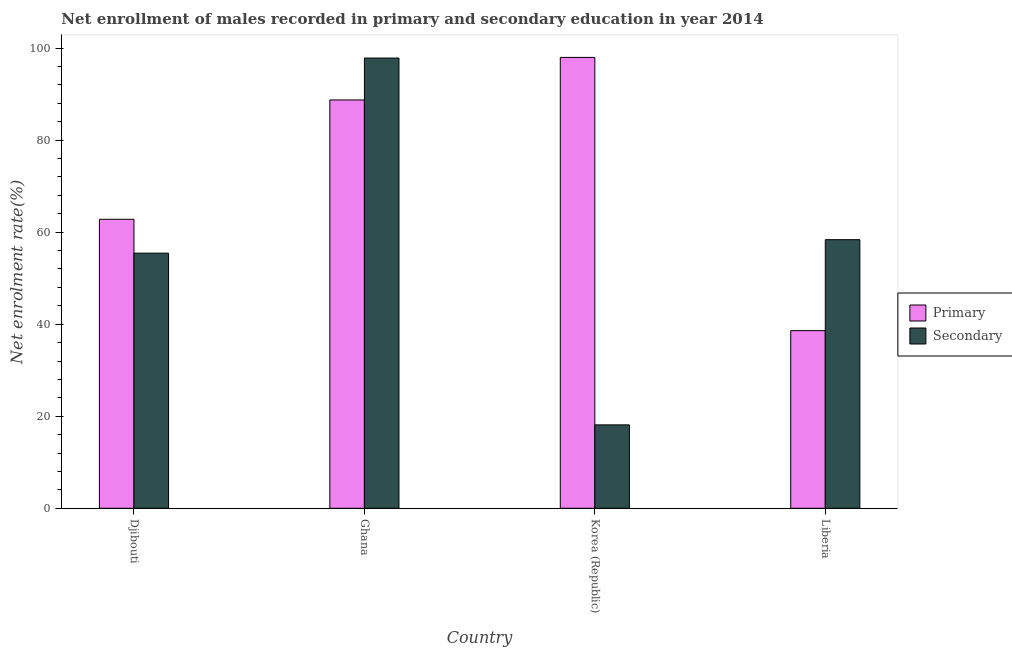Are the number of bars on each tick of the X-axis equal?
Your response must be concise. Yes. How many bars are there on the 3rd tick from the right?
Your answer should be very brief. 2. What is the label of the 4th group of bars from the left?
Your answer should be very brief. Liberia. What is the enrollment rate in secondary education in Liberia?
Keep it short and to the point. 58.37. Across all countries, what is the maximum enrollment rate in primary education?
Your answer should be very brief. 97.98. Across all countries, what is the minimum enrollment rate in primary education?
Offer a terse response. 38.6. In which country was the enrollment rate in primary education maximum?
Offer a very short reply. Korea (Republic). In which country was the enrollment rate in primary education minimum?
Provide a succinct answer. Liberia. What is the total enrollment rate in primary education in the graph?
Offer a terse response. 288.11. What is the difference between the enrollment rate in secondary education in Djibouti and that in Ghana?
Offer a very short reply. -42.4. What is the difference between the enrollment rate in primary education in Djibouti and the enrollment rate in secondary education in Korea (Republic)?
Keep it short and to the point. 44.68. What is the average enrollment rate in secondary education per country?
Provide a short and direct response. 57.44. What is the difference between the enrollment rate in secondary education and enrollment rate in primary education in Ghana?
Keep it short and to the point. 9.11. In how many countries, is the enrollment rate in secondary education greater than 96 %?
Ensure brevity in your answer.  1. What is the ratio of the enrollment rate in primary education in Ghana to that in Liberia?
Give a very brief answer. 2.3. Is the enrollment rate in secondary education in Ghana less than that in Korea (Republic)?
Provide a short and direct response. No. What is the difference between the highest and the second highest enrollment rate in primary education?
Offer a terse response. 9.24. What is the difference between the highest and the lowest enrollment rate in secondary education?
Your answer should be very brief. 79.71. In how many countries, is the enrollment rate in primary education greater than the average enrollment rate in primary education taken over all countries?
Provide a succinct answer. 2. Is the sum of the enrollment rate in primary education in Ghana and Liberia greater than the maximum enrollment rate in secondary education across all countries?
Provide a succinct answer. Yes. What does the 2nd bar from the left in Korea (Republic) represents?
Your answer should be compact. Secondary. What does the 1st bar from the right in Djibouti represents?
Give a very brief answer. Secondary. How many bars are there?
Your answer should be very brief. 8. Are all the bars in the graph horizontal?
Your response must be concise. No. What is the difference between two consecutive major ticks on the Y-axis?
Your answer should be very brief. 20. Are the values on the major ticks of Y-axis written in scientific E-notation?
Provide a short and direct response. No. How many legend labels are there?
Provide a succinct answer. 2. How are the legend labels stacked?
Keep it short and to the point. Vertical. What is the title of the graph?
Your answer should be very brief. Net enrollment of males recorded in primary and secondary education in year 2014. What is the label or title of the X-axis?
Give a very brief answer. Country. What is the label or title of the Y-axis?
Provide a succinct answer. Net enrolment rate(%). What is the Net enrolment rate(%) in Primary in Djibouti?
Your answer should be very brief. 62.8. What is the Net enrolment rate(%) in Secondary in Djibouti?
Provide a succinct answer. 55.44. What is the Net enrolment rate(%) in Primary in Ghana?
Provide a short and direct response. 88.73. What is the Net enrolment rate(%) of Secondary in Ghana?
Your answer should be very brief. 97.84. What is the Net enrolment rate(%) of Primary in Korea (Republic)?
Ensure brevity in your answer.  97.98. What is the Net enrolment rate(%) of Secondary in Korea (Republic)?
Provide a succinct answer. 18.13. What is the Net enrolment rate(%) of Primary in Liberia?
Keep it short and to the point. 38.6. What is the Net enrolment rate(%) in Secondary in Liberia?
Offer a very short reply. 58.37. Across all countries, what is the maximum Net enrolment rate(%) of Primary?
Ensure brevity in your answer.  97.98. Across all countries, what is the maximum Net enrolment rate(%) in Secondary?
Make the answer very short. 97.84. Across all countries, what is the minimum Net enrolment rate(%) of Primary?
Make the answer very short. 38.6. Across all countries, what is the minimum Net enrolment rate(%) in Secondary?
Ensure brevity in your answer.  18.13. What is the total Net enrolment rate(%) of Primary in the graph?
Offer a very short reply. 288.11. What is the total Net enrolment rate(%) of Secondary in the graph?
Keep it short and to the point. 229.78. What is the difference between the Net enrolment rate(%) in Primary in Djibouti and that in Ghana?
Keep it short and to the point. -25.93. What is the difference between the Net enrolment rate(%) of Secondary in Djibouti and that in Ghana?
Ensure brevity in your answer.  -42.4. What is the difference between the Net enrolment rate(%) of Primary in Djibouti and that in Korea (Republic)?
Provide a short and direct response. -35.18. What is the difference between the Net enrolment rate(%) of Secondary in Djibouti and that in Korea (Republic)?
Your response must be concise. 37.32. What is the difference between the Net enrolment rate(%) in Primary in Djibouti and that in Liberia?
Your response must be concise. 24.2. What is the difference between the Net enrolment rate(%) in Secondary in Djibouti and that in Liberia?
Provide a short and direct response. -2.93. What is the difference between the Net enrolment rate(%) of Primary in Ghana and that in Korea (Republic)?
Ensure brevity in your answer.  -9.24. What is the difference between the Net enrolment rate(%) of Secondary in Ghana and that in Korea (Republic)?
Provide a short and direct response. 79.71. What is the difference between the Net enrolment rate(%) of Primary in Ghana and that in Liberia?
Offer a very short reply. 50.13. What is the difference between the Net enrolment rate(%) of Secondary in Ghana and that in Liberia?
Your answer should be compact. 39.47. What is the difference between the Net enrolment rate(%) of Primary in Korea (Republic) and that in Liberia?
Make the answer very short. 59.38. What is the difference between the Net enrolment rate(%) in Secondary in Korea (Republic) and that in Liberia?
Offer a very short reply. -40.24. What is the difference between the Net enrolment rate(%) in Primary in Djibouti and the Net enrolment rate(%) in Secondary in Ghana?
Your response must be concise. -35.04. What is the difference between the Net enrolment rate(%) in Primary in Djibouti and the Net enrolment rate(%) in Secondary in Korea (Republic)?
Your answer should be very brief. 44.68. What is the difference between the Net enrolment rate(%) of Primary in Djibouti and the Net enrolment rate(%) of Secondary in Liberia?
Ensure brevity in your answer.  4.43. What is the difference between the Net enrolment rate(%) of Primary in Ghana and the Net enrolment rate(%) of Secondary in Korea (Republic)?
Give a very brief answer. 70.61. What is the difference between the Net enrolment rate(%) in Primary in Ghana and the Net enrolment rate(%) in Secondary in Liberia?
Keep it short and to the point. 30.36. What is the difference between the Net enrolment rate(%) in Primary in Korea (Republic) and the Net enrolment rate(%) in Secondary in Liberia?
Keep it short and to the point. 39.61. What is the average Net enrolment rate(%) in Primary per country?
Offer a very short reply. 72.03. What is the average Net enrolment rate(%) in Secondary per country?
Offer a terse response. 57.44. What is the difference between the Net enrolment rate(%) of Primary and Net enrolment rate(%) of Secondary in Djibouti?
Give a very brief answer. 7.36. What is the difference between the Net enrolment rate(%) of Primary and Net enrolment rate(%) of Secondary in Ghana?
Offer a terse response. -9.11. What is the difference between the Net enrolment rate(%) of Primary and Net enrolment rate(%) of Secondary in Korea (Republic)?
Keep it short and to the point. 79.85. What is the difference between the Net enrolment rate(%) in Primary and Net enrolment rate(%) in Secondary in Liberia?
Provide a short and direct response. -19.77. What is the ratio of the Net enrolment rate(%) in Primary in Djibouti to that in Ghana?
Provide a short and direct response. 0.71. What is the ratio of the Net enrolment rate(%) in Secondary in Djibouti to that in Ghana?
Ensure brevity in your answer.  0.57. What is the ratio of the Net enrolment rate(%) of Primary in Djibouti to that in Korea (Republic)?
Offer a very short reply. 0.64. What is the ratio of the Net enrolment rate(%) of Secondary in Djibouti to that in Korea (Republic)?
Make the answer very short. 3.06. What is the ratio of the Net enrolment rate(%) of Primary in Djibouti to that in Liberia?
Your response must be concise. 1.63. What is the ratio of the Net enrolment rate(%) of Secondary in Djibouti to that in Liberia?
Ensure brevity in your answer.  0.95. What is the ratio of the Net enrolment rate(%) in Primary in Ghana to that in Korea (Republic)?
Provide a succinct answer. 0.91. What is the ratio of the Net enrolment rate(%) in Secondary in Ghana to that in Korea (Republic)?
Provide a succinct answer. 5.4. What is the ratio of the Net enrolment rate(%) in Primary in Ghana to that in Liberia?
Your answer should be compact. 2.3. What is the ratio of the Net enrolment rate(%) of Secondary in Ghana to that in Liberia?
Offer a very short reply. 1.68. What is the ratio of the Net enrolment rate(%) of Primary in Korea (Republic) to that in Liberia?
Provide a short and direct response. 2.54. What is the ratio of the Net enrolment rate(%) in Secondary in Korea (Republic) to that in Liberia?
Keep it short and to the point. 0.31. What is the difference between the highest and the second highest Net enrolment rate(%) in Primary?
Your response must be concise. 9.24. What is the difference between the highest and the second highest Net enrolment rate(%) of Secondary?
Keep it short and to the point. 39.47. What is the difference between the highest and the lowest Net enrolment rate(%) in Primary?
Provide a short and direct response. 59.38. What is the difference between the highest and the lowest Net enrolment rate(%) of Secondary?
Keep it short and to the point. 79.71. 